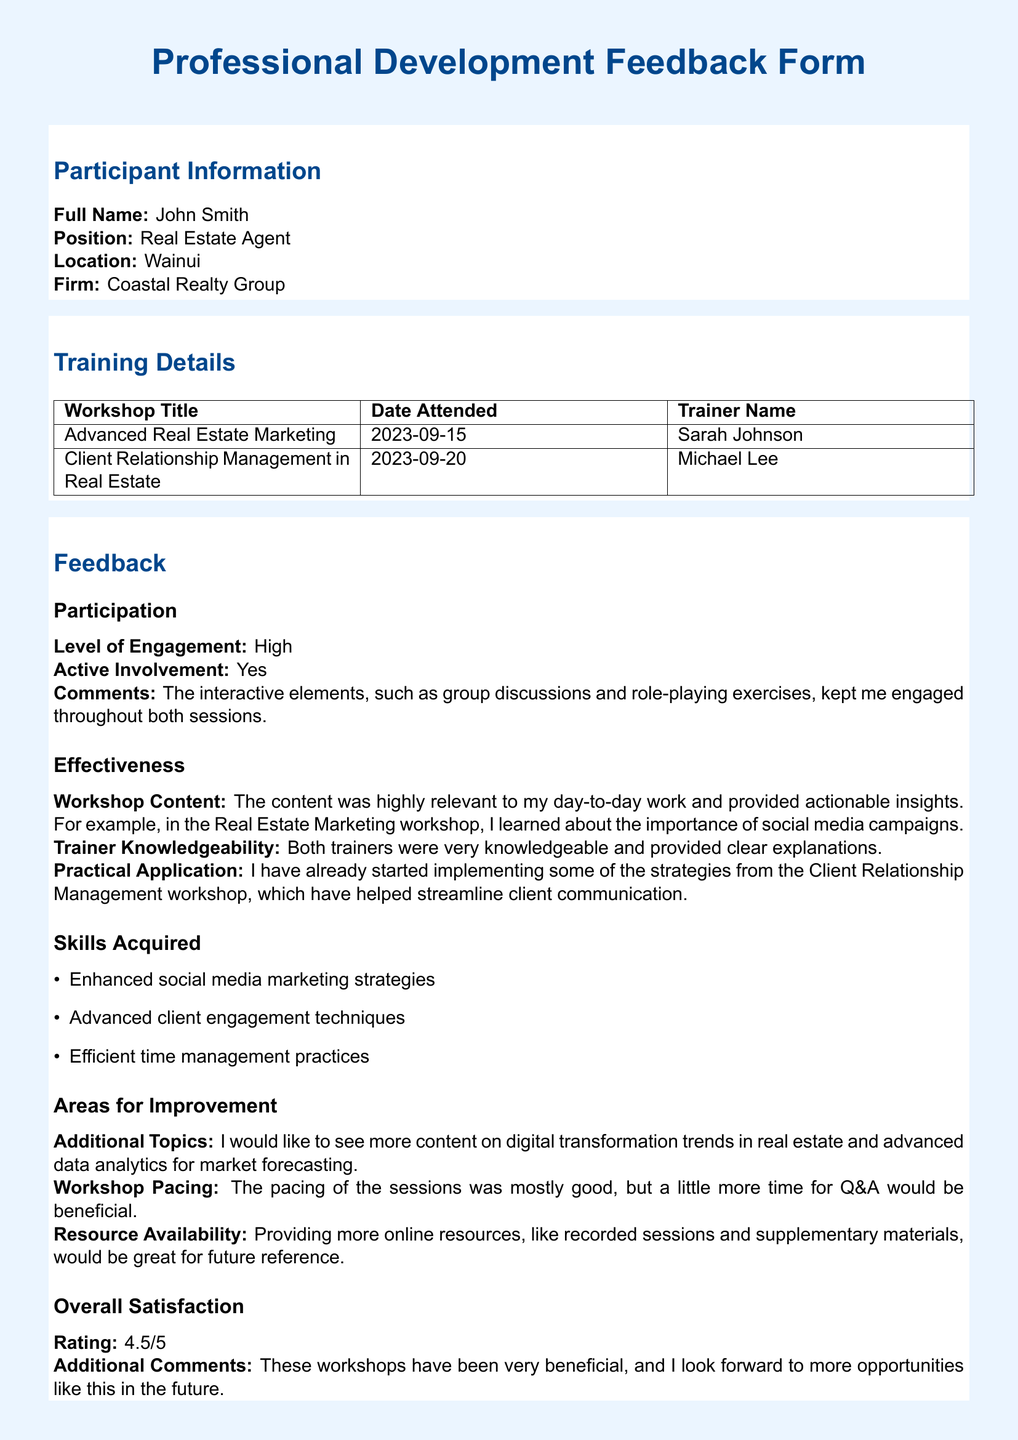what is the participant's full name? The participant's full name is listed under the Participant Information section.
Answer: John Smith what position does the participant hold? The position is stated in the Participant Information section.
Answer: Real Estate Agent what is the title of the first workshop attended? The first workshop title is provided in the Training Details section.
Answer: Advanced Real Estate Marketing who was the trainer for the Client Relationship Management workshop? The trainer for this workshop is mentioned in the Training Details section.
Answer: Michael Lee what rating did the participant give for overall satisfaction? The overall satisfaction rating is found in the Feedback section.
Answer: 4.5/5 what was a skill acquired during the training? Skills acquired are listed in the Skills Acquired subsection.
Answer: Enhanced social media marketing strategies what improvements does the participant suggest for future workshops? Suggestions for improvements are mentioned in the Areas for Improvement subsection.
Answer: More content on digital transformation trends in real estate how engaged was the participant during the workshops? The level of engagement is specified in the Participation subsection of Feedback.
Answer: High what date was the Client Relationship Management workshop attended? The date is provided in the Training Details section.
Answer: 2023-09-20 